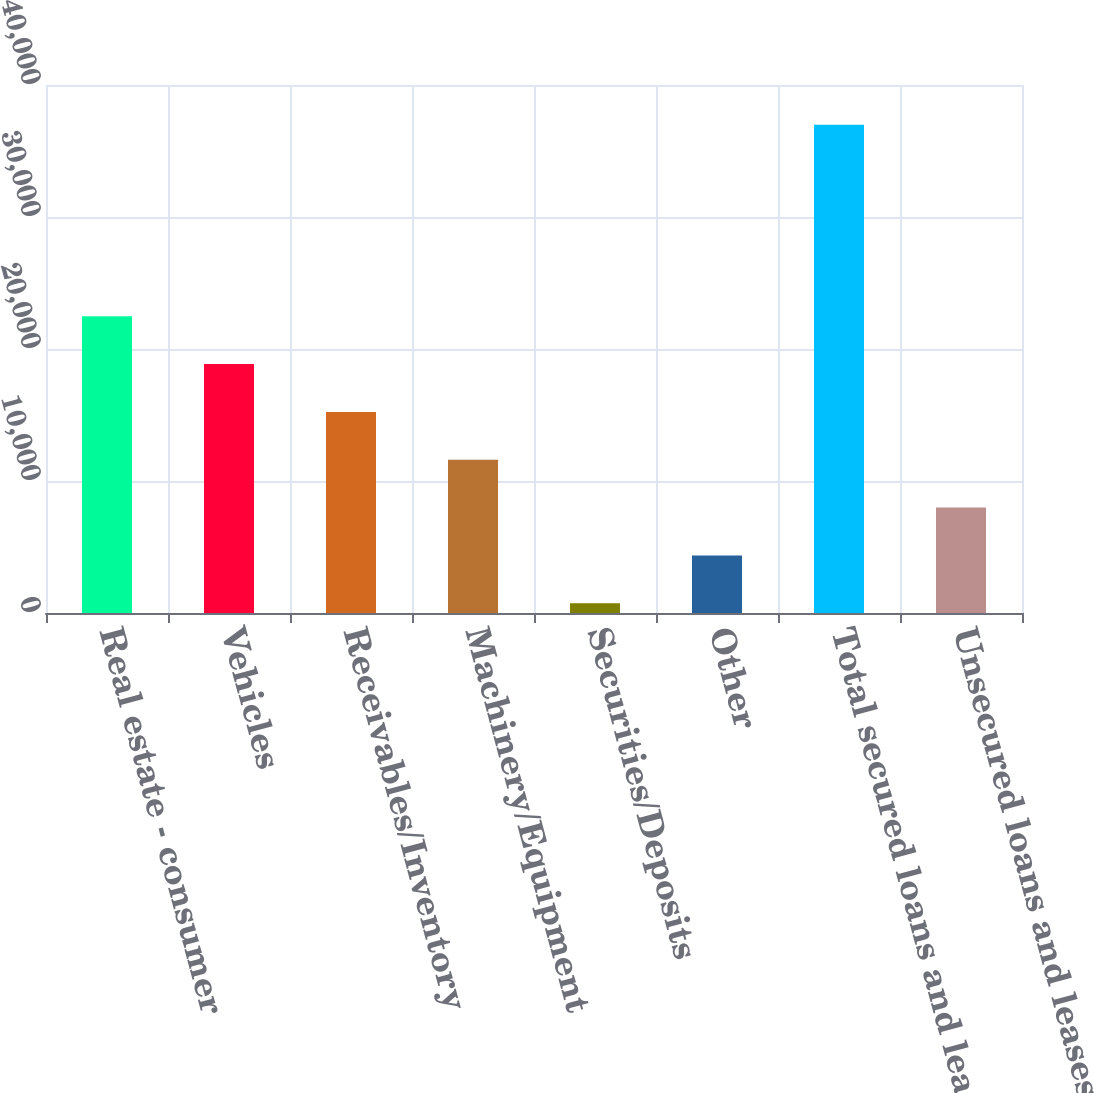Convert chart to OTSL. <chart><loc_0><loc_0><loc_500><loc_500><bar_chart><fcel>Real estate - consumer<fcel>Vehicles<fcel>Receivables/Inventory<fcel>Machinery/Equipment<fcel>Securities/Deposits<fcel>Other<fcel>Total secured loans and leases<fcel>Unsecured loans and leases<nl><fcel>22487.6<fcel>18862<fcel>15236.4<fcel>11610.8<fcel>734<fcel>4359.6<fcel>36990<fcel>7985.2<nl></chart> 